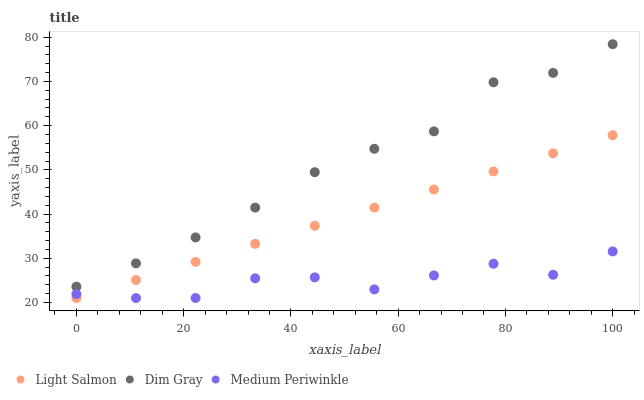Does Medium Periwinkle have the minimum area under the curve?
Answer yes or no. Yes. Does Dim Gray have the maximum area under the curve?
Answer yes or no. Yes. Does Dim Gray have the minimum area under the curve?
Answer yes or no. No. Does Medium Periwinkle have the maximum area under the curve?
Answer yes or no. No. Is Light Salmon the smoothest?
Answer yes or no. Yes. Is Medium Periwinkle the roughest?
Answer yes or no. Yes. Is Dim Gray the smoothest?
Answer yes or no. No. Is Dim Gray the roughest?
Answer yes or no. No. Does Light Salmon have the lowest value?
Answer yes or no. Yes. Does Dim Gray have the lowest value?
Answer yes or no. No. Does Dim Gray have the highest value?
Answer yes or no. Yes. Does Medium Periwinkle have the highest value?
Answer yes or no. No. Is Light Salmon less than Dim Gray?
Answer yes or no. Yes. Is Dim Gray greater than Medium Periwinkle?
Answer yes or no. Yes. Does Medium Periwinkle intersect Light Salmon?
Answer yes or no. Yes. Is Medium Periwinkle less than Light Salmon?
Answer yes or no. No. Is Medium Periwinkle greater than Light Salmon?
Answer yes or no. No. Does Light Salmon intersect Dim Gray?
Answer yes or no. No. 